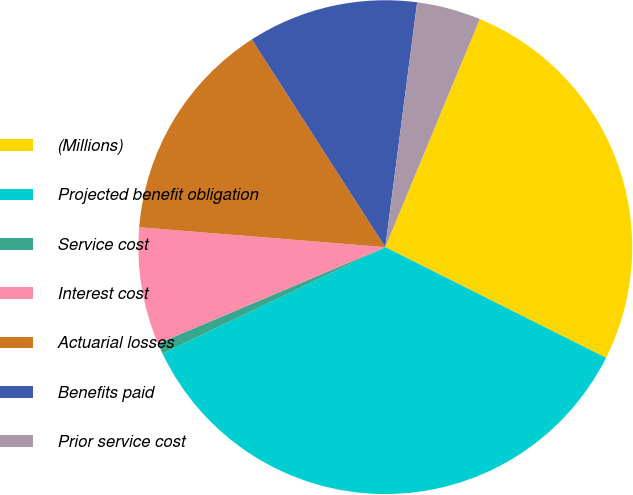Convert chart. <chart><loc_0><loc_0><loc_500><loc_500><pie_chart><fcel>(Millions)<fcel>Projected benefit obligation<fcel>Service cost<fcel>Interest cost<fcel>Actuarial losses<fcel>Benefits paid<fcel>Prior service cost<nl><fcel>26.15%<fcel>35.51%<fcel>0.71%<fcel>7.67%<fcel>14.63%<fcel>11.15%<fcel>4.19%<nl></chart> 